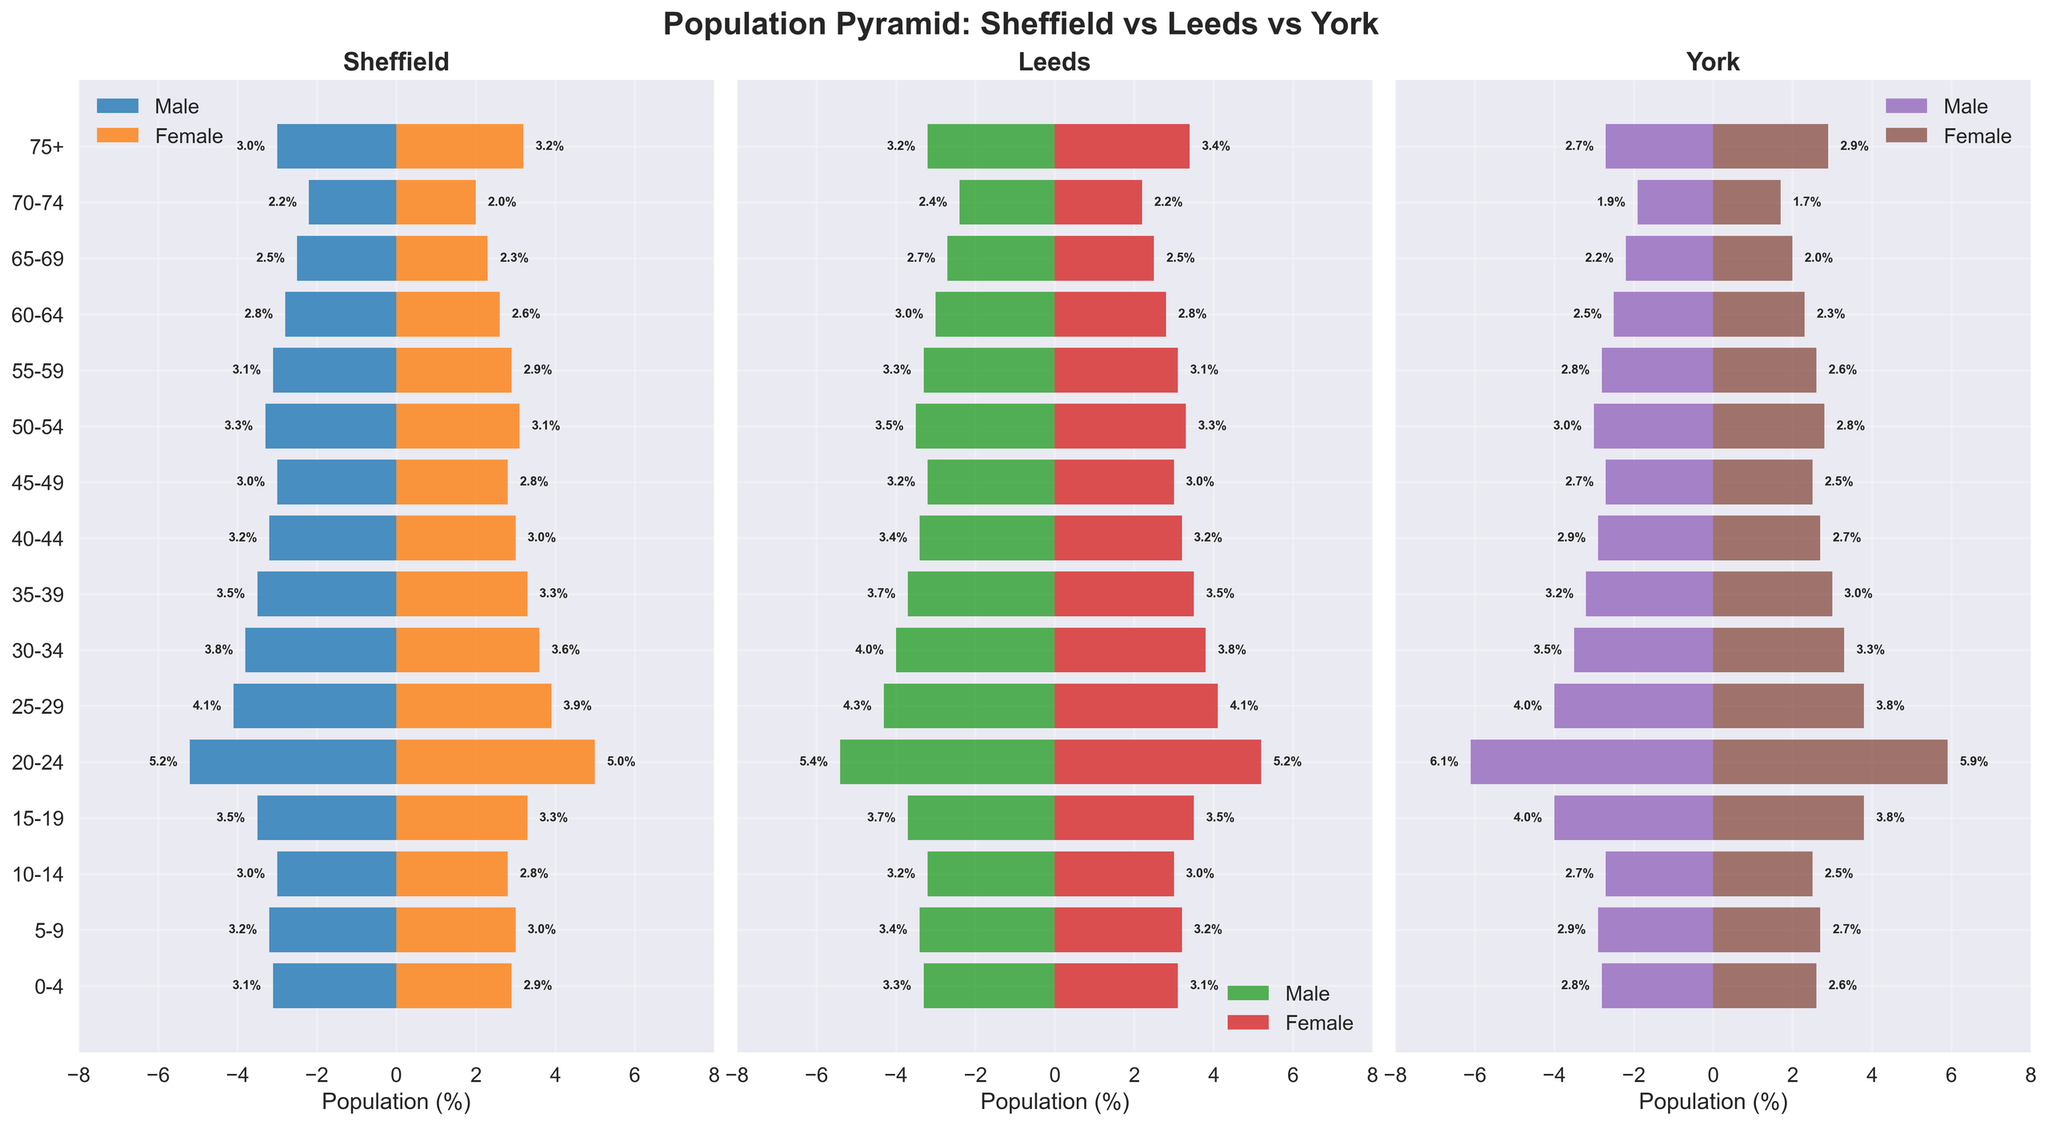Which city has the highest percentage of males aged 20-24? By examining the bars for the 20-24 age group across the three cities, York has 6.1% males, compared to Leeds with 5.4% and Sheffield with 5.2%.
Answer: York How does the population percentage of females aged 75+ in Leeds compare to that in Sheffield? Leeds has about 3.4% females in the 75+ age group, whereas Sheffield has about 3.2%. Thus, Leeds has a slightly higher percentage in this category.
Answer: Leeds has a higher percentage Which city has the most balanced gender distribution in the 0-4 age group? By looking at the difference between the male and female percentages for each city in the 0-4 age group: Sheffield (0.2%), Leeds (0.2%), and York (0.2%). All cities have almost the same slight imbalance.
Answer: All cities What is the overall trend in the young adult population (20-24) across the three cities? The trend shows that York has the highest percentages (males 6.1%, females 5.9%), followed by Leeds (males 5.4%, females 5.2%), and Sheffield (males 5.2%, females 5.0%).
Answer: York > Leeds > Sheffield How does the male population percentage aged 35-39 in Sheffield compare to York? Sheffield has 3.5% males aged 35-39, whereas York has 3.2%. Thus, Sheffield has a slightly higher percentage.
Answer: Sheffield has a higher percentage Which age group has the least population percentage in York? In York, the age group 70-74 has the least population percentage, with 1.9% males and 1.7% females.
Answer: 70-74 age group For which age groups do both genders in Sheffield have exactly the same population percentage? In the age groups 5-9 and 60-64, both males and females in Sheffield have population percentages of 3.2% and 2.8% respectively.
Answer: 5-9 and 60-64 What is the combined male and female percentage in the 25-29 age group in Leeds? The combined percentage for males and females in the 25-29 age group in Leeds is 4.3% males + 4.1% females = 8.4%.
Answer: 8.4% How does the male population percentage aged 65-69 in Sheffield compare to Leeds? Sheffield has 2.5% males aged 65-69, whereas Leeds has 2.7%. Thus, Leeds has a slightly higher percentage.
Answer: Leeds has a higher percentage Are there any age groups in York where the female population percentage is higher than the male percentage by more than 1%? In York, there are no age groups where the female percentage is higher than the male percentage by more than 1%.
Answer: No 